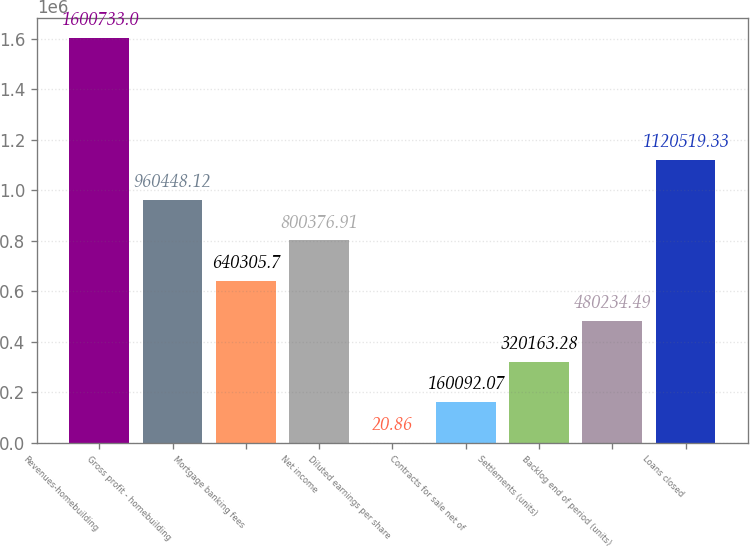Convert chart to OTSL. <chart><loc_0><loc_0><loc_500><loc_500><bar_chart><fcel>Revenues-homebuilding<fcel>Gross profit - homebuilding<fcel>Mortgage banking fees<fcel>Net income<fcel>Diluted earnings per share<fcel>Contracts for sale net of<fcel>Settlements (units)<fcel>Backlog end of period (units)<fcel>Loans closed<nl><fcel>1.60073e+06<fcel>960448<fcel>640306<fcel>800377<fcel>20.86<fcel>160092<fcel>320163<fcel>480234<fcel>1.12052e+06<nl></chart> 